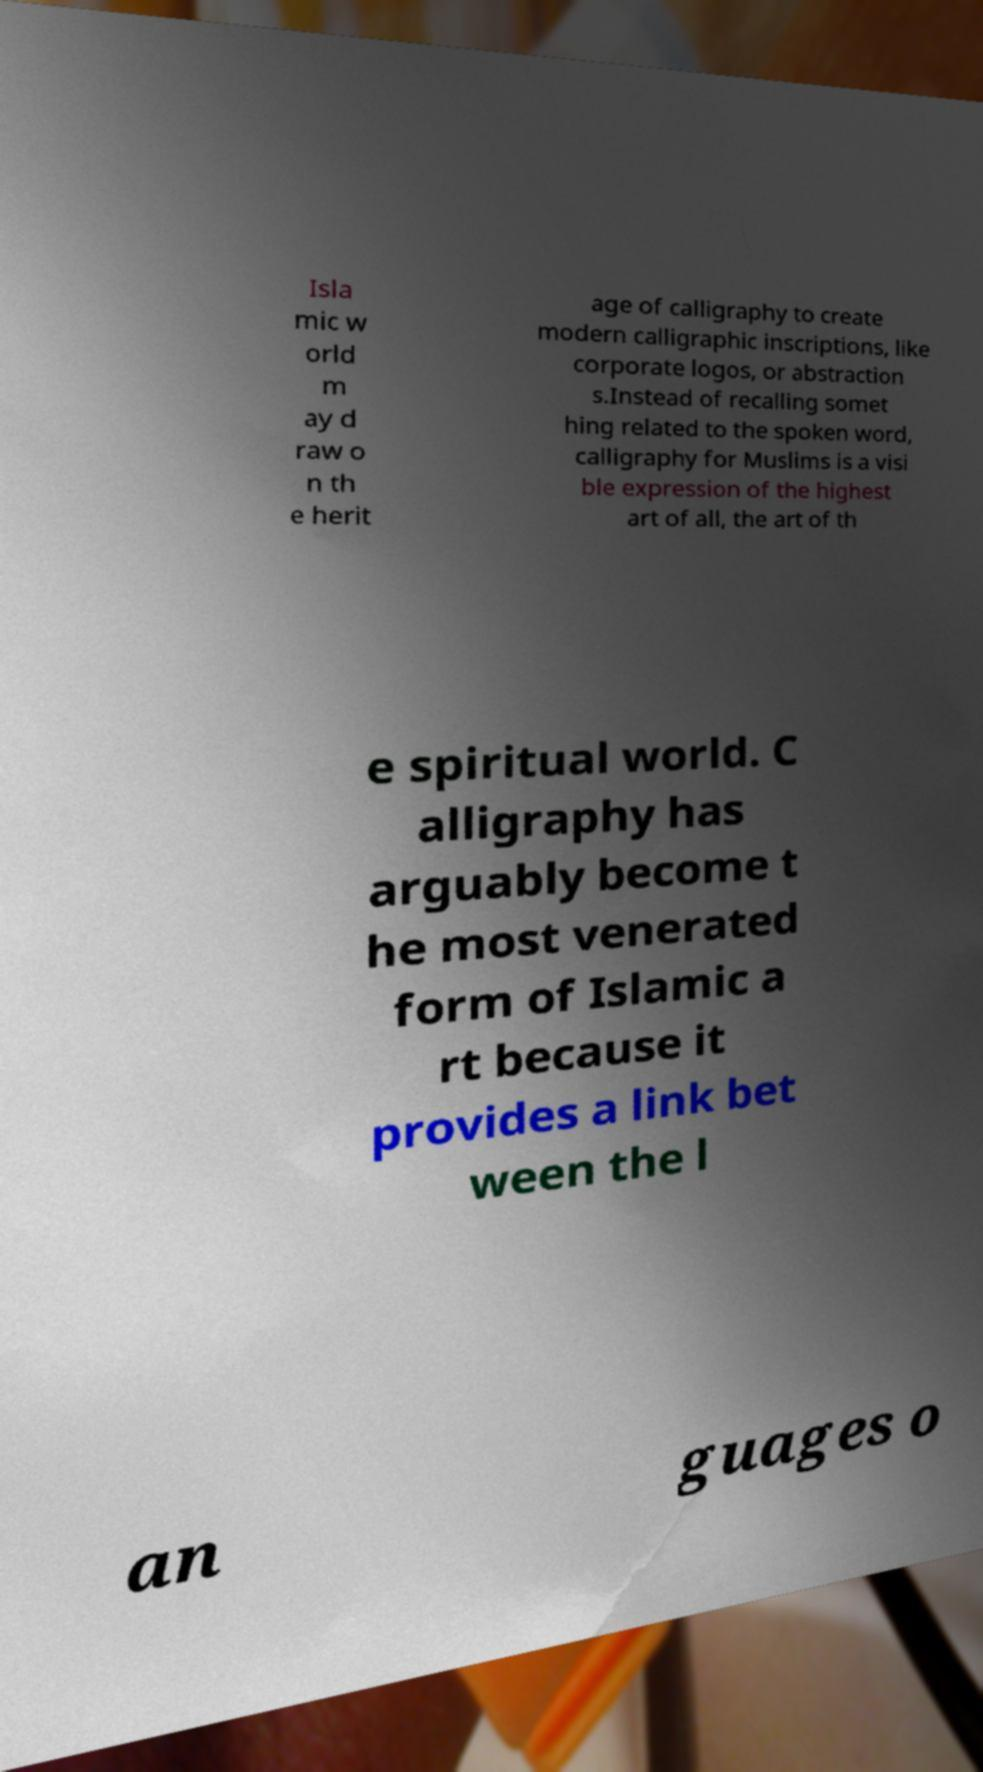I need the written content from this picture converted into text. Can you do that? Isla mic w orld m ay d raw o n th e herit age of calligraphy to create modern calligraphic inscriptions, like corporate logos, or abstraction s.Instead of recalling somet hing related to the spoken word, calligraphy for Muslims is a visi ble expression of the highest art of all, the art of th e spiritual world. C alligraphy has arguably become t he most venerated form of Islamic a rt because it provides a link bet ween the l an guages o 